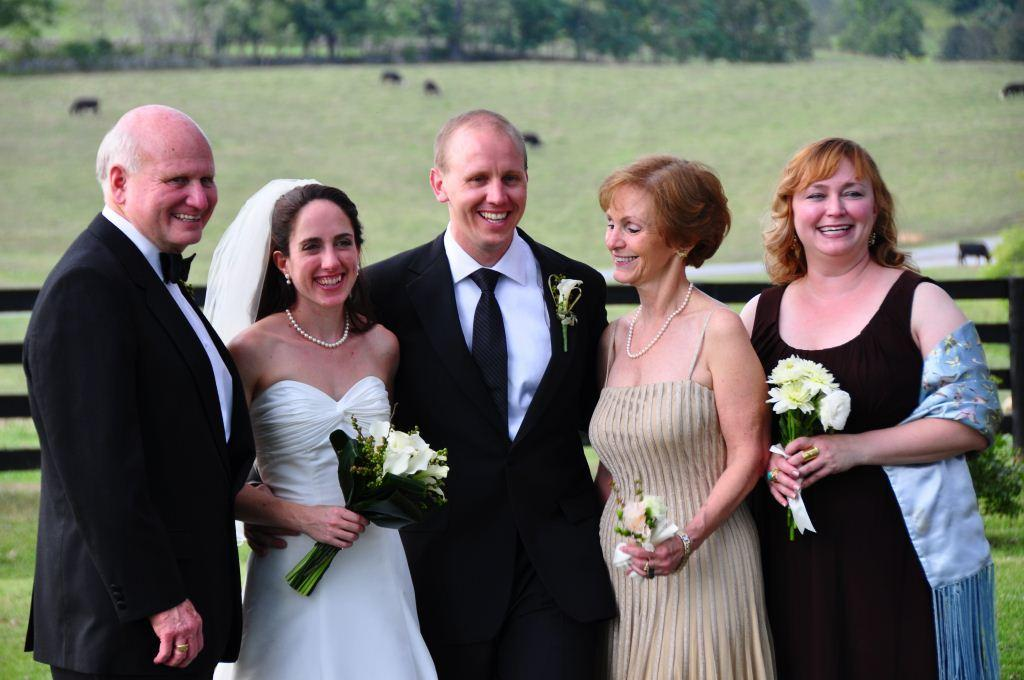How many people are in the image? There is a group of people in the image. What is the mood of the people in the image? The people are smiling in the image. What are some people holding in the image? Some people are holding bouquets in the image. What type of natural environment is visible in the image? There is grass, trees, and a fence visible in the image. What other living beings can be seen in the image? There are animals in the image. What is the name of the father in the image? There is no mention of a father or any specific individuals in the image. 